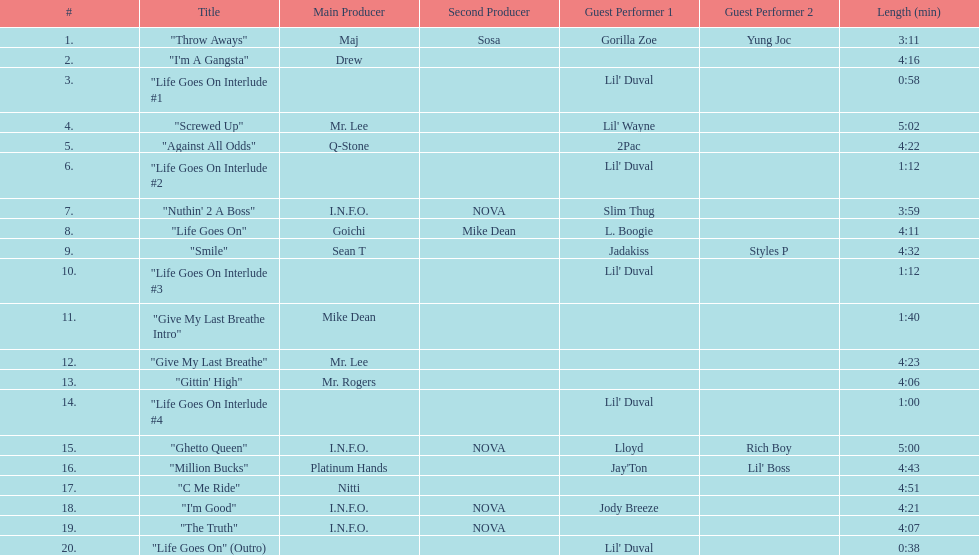What is the first track featuring lil' duval? "Life Goes On Interlude #1. 